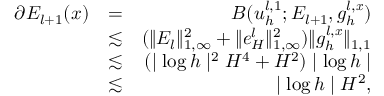<formula> <loc_0><loc_0><loc_500><loc_500>\begin{array} { r l r } { \partial E _ { l + 1 } ( x ) } & { = } & { B ( u _ { h } ^ { l , 1 } ; E _ { l + 1 } , g _ { h } ^ { l , x } ) } \\ & { \lesssim } & { ( \| E _ { l } \| _ { 1 , \infty } ^ { 2 } + \| e _ { H } ^ { l } \| _ { 1 , \infty } ^ { 2 } ) \| g _ { h } ^ { l , x } \| _ { 1 , 1 } } \\ & { \lesssim } & { ( | \log h | ^ { 2 } H ^ { 4 } + H ^ { 2 } ) | \log h | } \\ & { \lesssim } & { | \log h | H ^ { 2 } , } \end{array}</formula> 